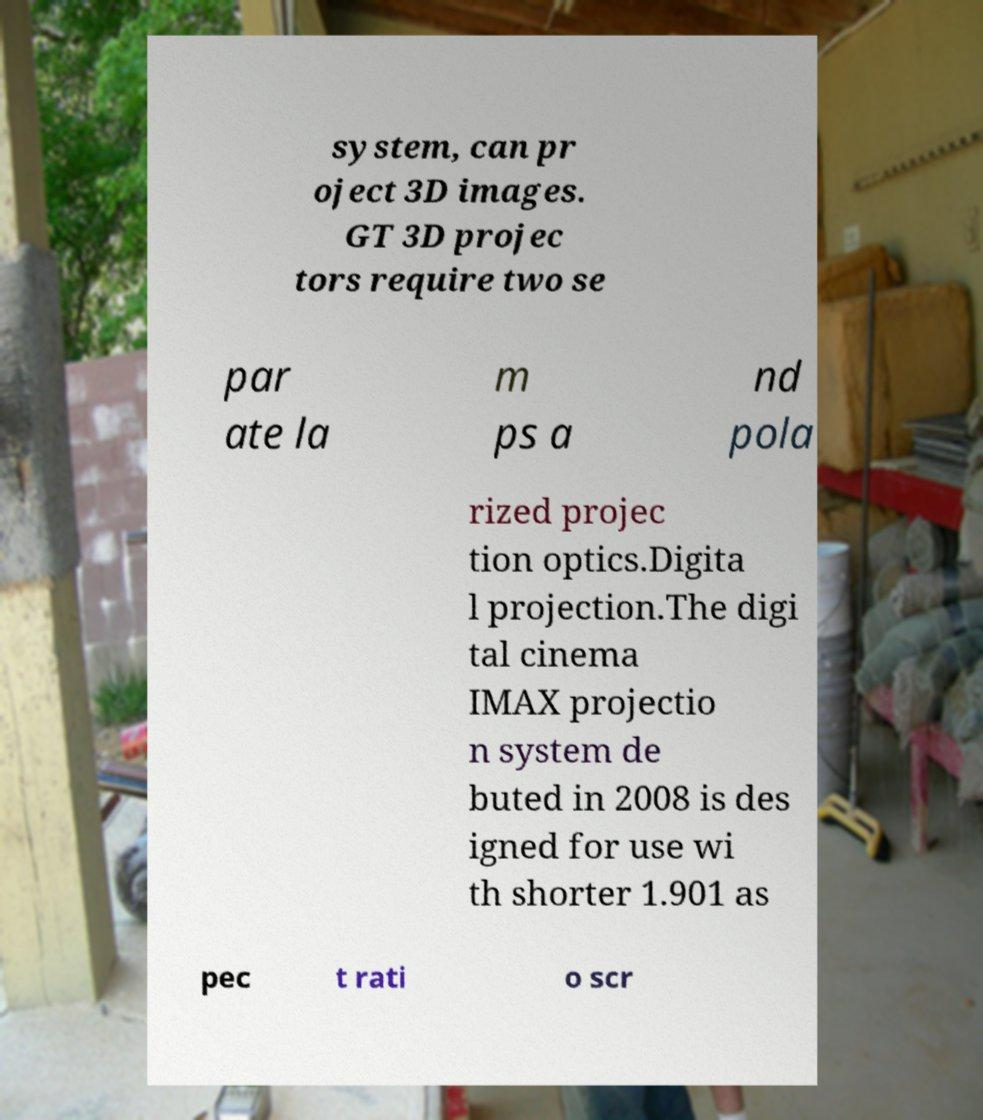I need the written content from this picture converted into text. Can you do that? system, can pr oject 3D images. GT 3D projec tors require two se par ate la m ps a nd pola rized projec tion optics.Digita l projection.The digi tal cinema IMAX projectio n system de buted in 2008 is des igned for use wi th shorter 1.901 as pec t rati o scr 